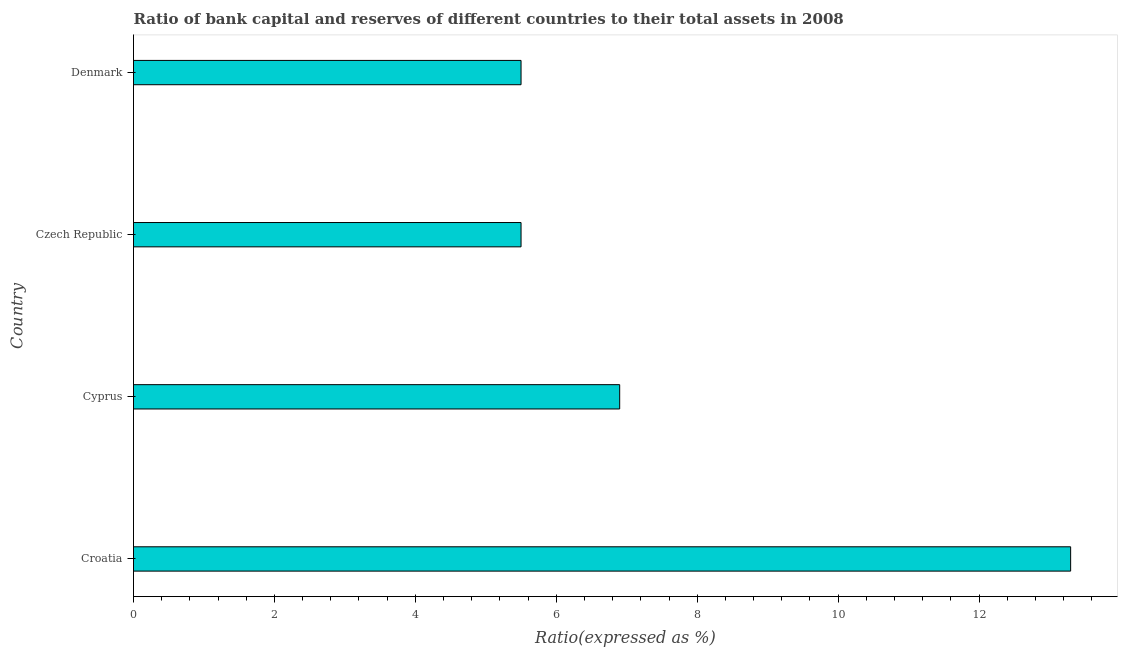What is the title of the graph?
Offer a terse response. Ratio of bank capital and reserves of different countries to their total assets in 2008. What is the label or title of the X-axis?
Provide a short and direct response. Ratio(expressed as %). What is the label or title of the Y-axis?
Offer a terse response. Country. Across all countries, what is the maximum bank capital to assets ratio?
Offer a terse response. 13.3. Across all countries, what is the minimum bank capital to assets ratio?
Offer a terse response. 5.5. In which country was the bank capital to assets ratio maximum?
Your response must be concise. Croatia. In which country was the bank capital to assets ratio minimum?
Provide a short and direct response. Czech Republic. What is the sum of the bank capital to assets ratio?
Give a very brief answer. 31.2. What is the difference between the bank capital to assets ratio in Czech Republic and Denmark?
Offer a very short reply. 0. What is the average bank capital to assets ratio per country?
Your answer should be very brief. 7.8. What is the median bank capital to assets ratio?
Your answer should be very brief. 6.2. What is the ratio of the bank capital to assets ratio in Croatia to that in Denmark?
Offer a very short reply. 2.42. Is the bank capital to assets ratio in Croatia less than that in Czech Republic?
Give a very brief answer. No. Is the difference between the bank capital to assets ratio in Cyprus and Denmark greater than the difference between any two countries?
Your response must be concise. No. Is the sum of the bank capital to assets ratio in Cyprus and Denmark greater than the maximum bank capital to assets ratio across all countries?
Make the answer very short. No. How many countries are there in the graph?
Your answer should be compact. 4. What is the difference between two consecutive major ticks on the X-axis?
Offer a terse response. 2. Are the values on the major ticks of X-axis written in scientific E-notation?
Your answer should be compact. No. What is the Ratio(expressed as %) of Cyprus?
Keep it short and to the point. 6.9. What is the Ratio(expressed as %) of Czech Republic?
Offer a terse response. 5.5. What is the difference between the Ratio(expressed as %) in Croatia and Denmark?
Provide a short and direct response. 7.8. What is the difference between the Ratio(expressed as %) in Cyprus and Czech Republic?
Offer a very short reply. 1.4. What is the difference between the Ratio(expressed as %) in Cyprus and Denmark?
Your answer should be very brief. 1.4. What is the ratio of the Ratio(expressed as %) in Croatia to that in Cyprus?
Ensure brevity in your answer.  1.93. What is the ratio of the Ratio(expressed as %) in Croatia to that in Czech Republic?
Your answer should be very brief. 2.42. What is the ratio of the Ratio(expressed as %) in Croatia to that in Denmark?
Provide a succinct answer. 2.42. What is the ratio of the Ratio(expressed as %) in Cyprus to that in Czech Republic?
Your response must be concise. 1.25. What is the ratio of the Ratio(expressed as %) in Cyprus to that in Denmark?
Offer a very short reply. 1.25. 